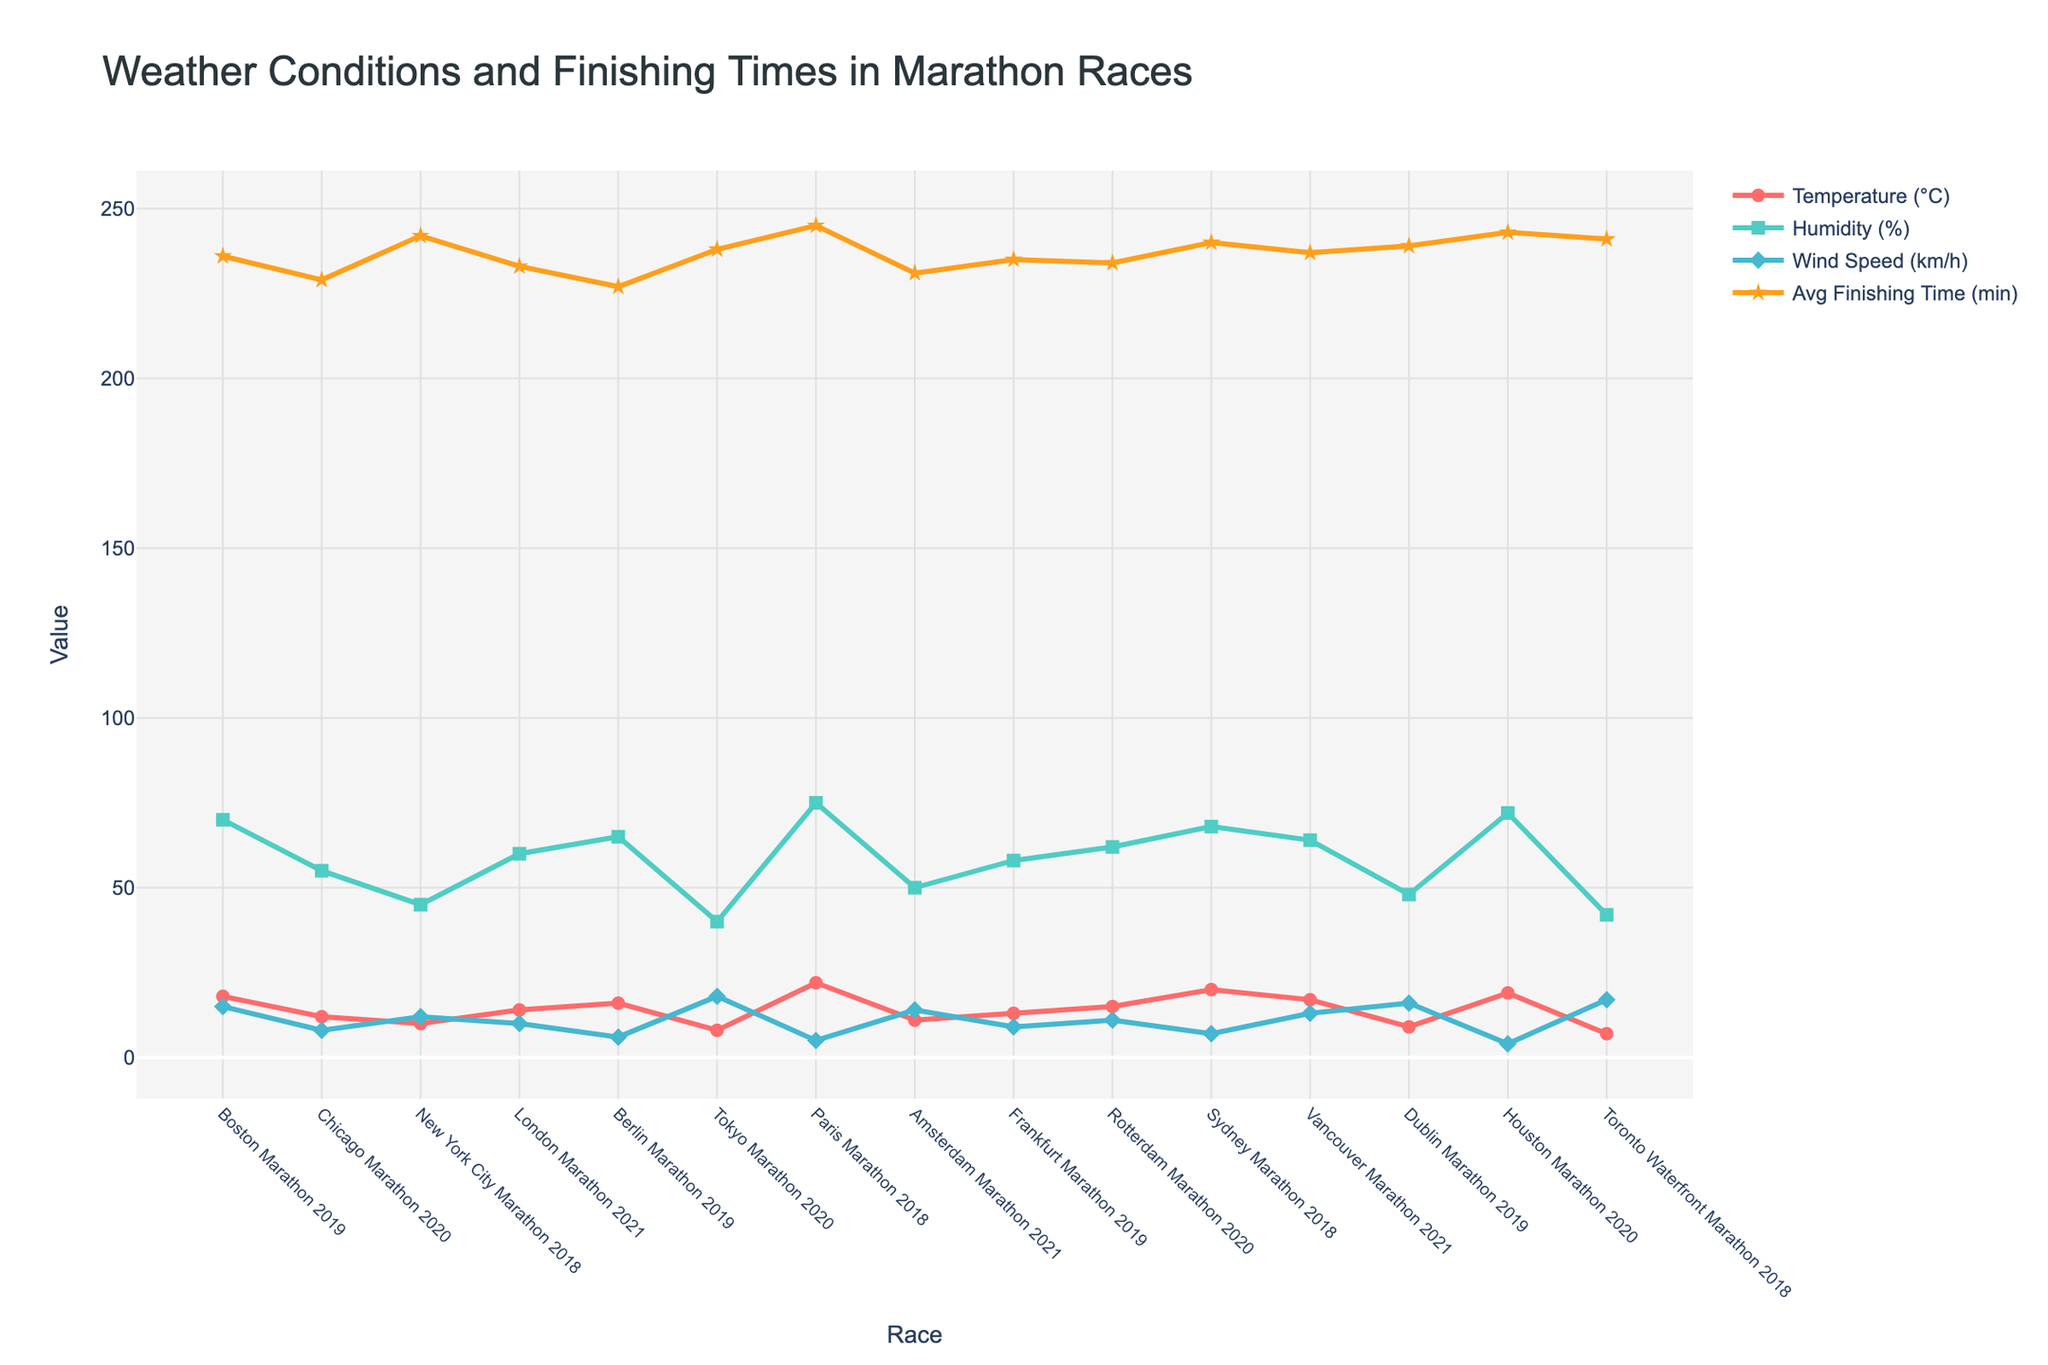Which marathon had the highest average finishing time? To find this, look for the peak point on the line for average finishing times (stars) in the chart.
Answer: Paris Marathon 2018 Which marathon had the lowest temperature? Identify the trough point on the line for temperature (circles) in the chart.
Answer: Toronto Waterfront Marathon 2018 What is the difference between the average finishing times for the Sydney Marathon 2018 and the Tokyo Marathon 2020? Find the average finishing times (stars) for both marathons and subtract the Tokyo value from the Sydney value.
Answer: 2 minutes Which race had a higher wind speed, the Amsterdam Marathon 2021 or the Vancouver Marathon 2021? Compare the height of the lines for wind speed (diamonds) for both marathons.
Answer: Vancouver Marathon 2021 Order the races based on temperature from highest to lowest. Trace the line for temperature (circles) and record the temperatures in descending order.
Answer: Paris Marathon 2018, Sydney Marathon 2018, Houston Marathon 2020, Boston Marathon 2019, Vancouver Marathon 2021, Berlin Marathon 2019, Rotterdam Marathon 2020, London Marathon 2021, Frankfurt Marathon 2019, Chicago Marathon 2020, Amsterdam Marathon 2021, New York City Marathon 2018, Dublin Marathon 2019, Tokyo Marathon 2020, Toronto Waterfront Marathon 2018 Is there a correlation between temperature and average finishing time? Examine if higher temperatures correspond to higher average finishing times by analyzing the trends of the circles (temperature) and stars (average finishing time).
Answer: Higher temperatures generally correlate with higher average finishing times Which race had a humidity percentage closest to 60%? Look for a point on the line for humidity (squares) that is approximately 60%.
Answer: Rotterdam Marathon 2020 How did wind speed in Sydney Marathon 2018 compare to the wind speed in Boston Marathon 2019? Compare the points on the line for wind speed (diamonds) for both marathons.
Answer: Sydney Marathon 2018 had a lower wind speed Which race had the highest humidity? Identify the peak point on the line for humidity (squares).
Answer: Paris Marathon 2018 What’s the total of all average finishing times from all the races displayed? Sum all the average finishing times (stars) from each race.
Answer: 3,510 minutes 